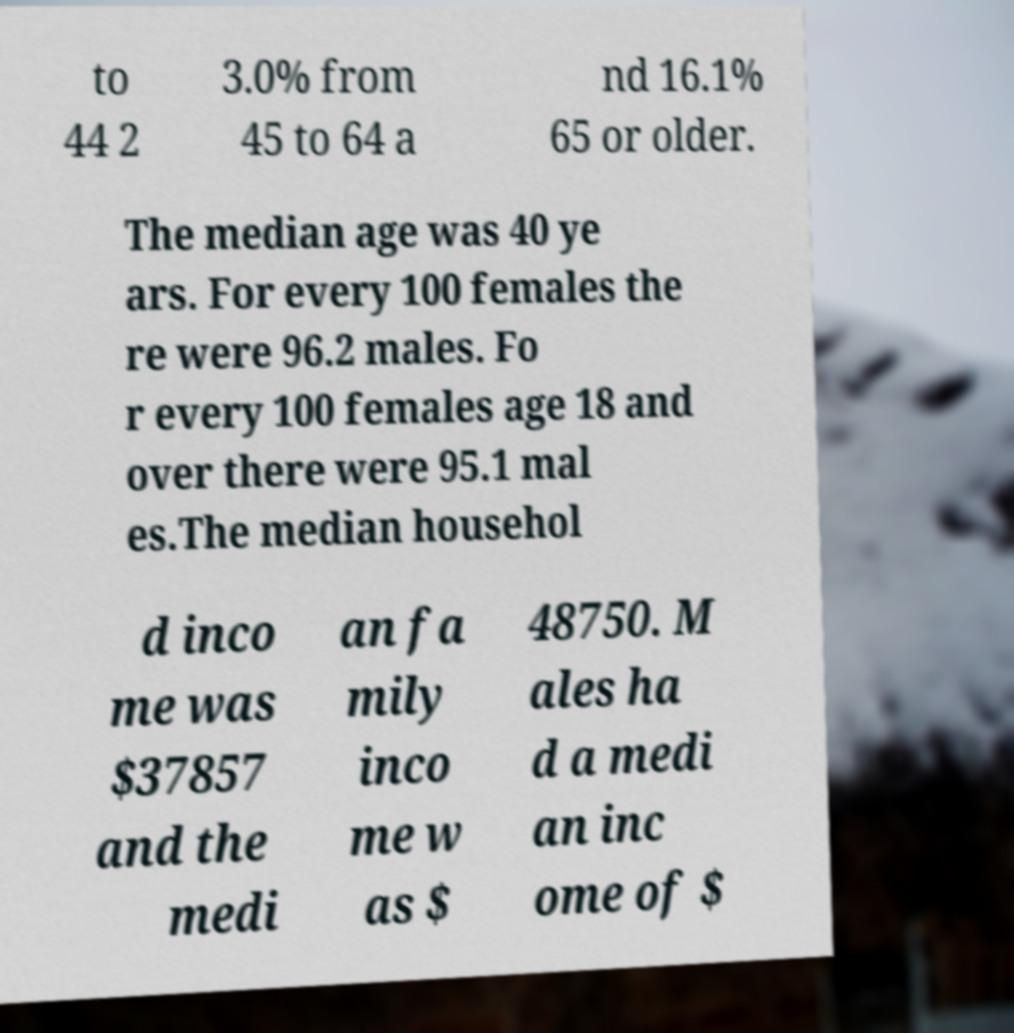For documentation purposes, I need the text within this image transcribed. Could you provide that? to 44 2 3.0% from 45 to 64 a nd 16.1% 65 or older. The median age was 40 ye ars. For every 100 females the re were 96.2 males. Fo r every 100 females age 18 and over there were 95.1 mal es.The median househol d inco me was $37857 and the medi an fa mily inco me w as $ 48750. M ales ha d a medi an inc ome of $ 